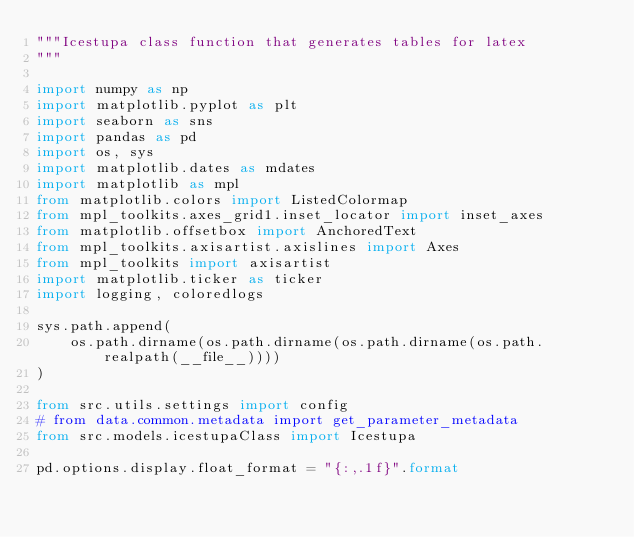Convert code to text. <code><loc_0><loc_0><loc_500><loc_500><_Python_>"""Icestupa class function that generates tables for latex
"""

import numpy as np
import matplotlib.pyplot as plt
import seaborn as sns
import pandas as pd
import os, sys
import matplotlib.dates as mdates
import matplotlib as mpl
from matplotlib.colors import ListedColormap
from mpl_toolkits.axes_grid1.inset_locator import inset_axes
from matplotlib.offsetbox import AnchoredText
from mpl_toolkits.axisartist.axislines import Axes
from mpl_toolkits import axisartist
import matplotlib.ticker as ticker
import logging, coloredlogs

sys.path.append(
    os.path.dirname(os.path.dirname(os.path.dirname(os.path.realpath(__file__))))
)

from src.utils.settings import config
# from data.common.metadata import get_parameter_metadata
from src.models.icestupaClass import Icestupa

pd.options.display.float_format = "{:,.1f}".format
</code> 